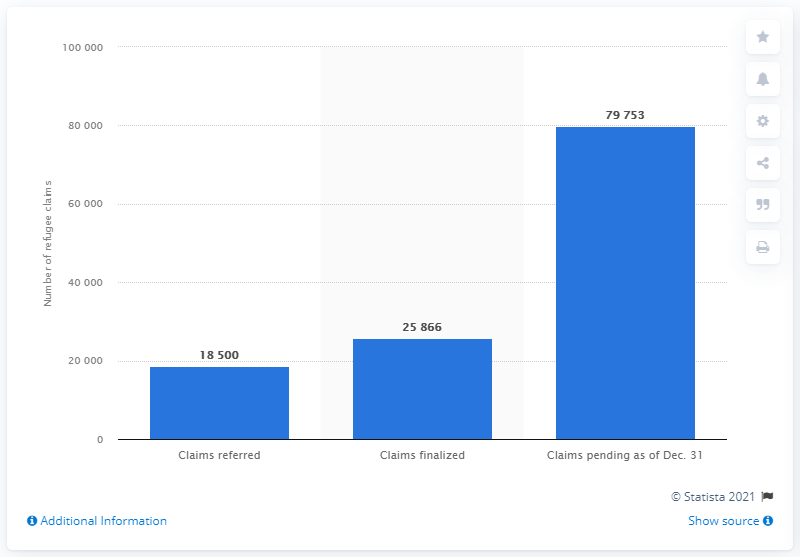Identify some key points in this picture. The number of refugee claims that were referred to the Immigration and Refugee Board (IRB) by the end of 2020 was 79,753. 